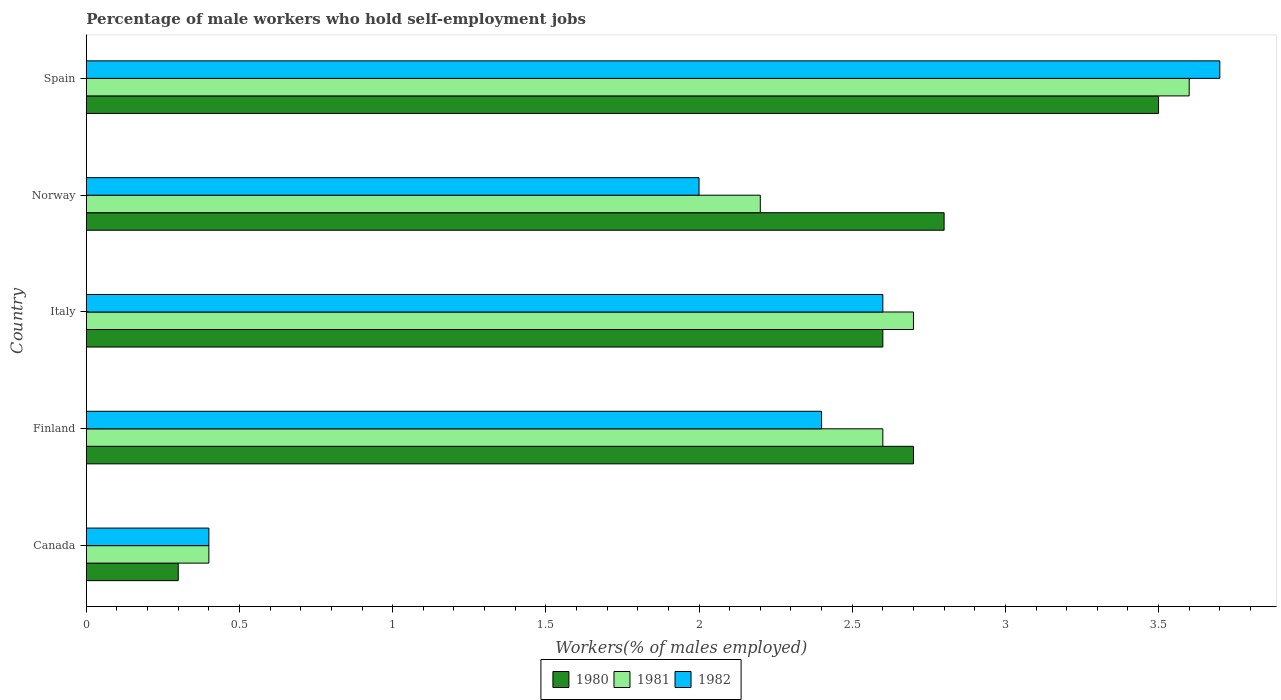Are the number of bars on each tick of the Y-axis equal?
Your answer should be very brief. Yes. How many bars are there on the 5th tick from the top?
Your response must be concise. 3. What is the label of the 4th group of bars from the top?
Ensure brevity in your answer.  Finland. What is the percentage of self-employed male workers in 1982 in Norway?
Give a very brief answer. 2. Across all countries, what is the maximum percentage of self-employed male workers in 1981?
Offer a terse response. 3.6. Across all countries, what is the minimum percentage of self-employed male workers in 1980?
Provide a short and direct response. 0.3. In which country was the percentage of self-employed male workers in 1982 maximum?
Give a very brief answer. Spain. In which country was the percentage of self-employed male workers in 1981 minimum?
Offer a very short reply. Canada. What is the total percentage of self-employed male workers in 1982 in the graph?
Offer a terse response. 11.1. What is the difference between the percentage of self-employed male workers in 1981 in Finland and that in Italy?
Offer a very short reply. -0.1. What is the difference between the percentage of self-employed male workers in 1980 in Spain and the percentage of self-employed male workers in 1981 in Canada?
Make the answer very short. 3.1. What is the average percentage of self-employed male workers in 1980 per country?
Your response must be concise. 2.38. What is the difference between the percentage of self-employed male workers in 1981 and percentage of self-employed male workers in 1980 in Canada?
Make the answer very short. 0.1. What is the ratio of the percentage of self-employed male workers in 1982 in Finland to that in Italy?
Keep it short and to the point. 0.92. Is the difference between the percentage of self-employed male workers in 1981 in Canada and Finland greater than the difference between the percentage of self-employed male workers in 1980 in Canada and Finland?
Provide a short and direct response. Yes. What is the difference between the highest and the second highest percentage of self-employed male workers in 1981?
Keep it short and to the point. 0.9. What is the difference between the highest and the lowest percentage of self-employed male workers in 1982?
Ensure brevity in your answer.  3.3. How many bars are there?
Your answer should be compact. 15. Are the values on the major ticks of X-axis written in scientific E-notation?
Offer a very short reply. No. Does the graph contain any zero values?
Offer a terse response. No. Where does the legend appear in the graph?
Your answer should be compact. Bottom center. How many legend labels are there?
Provide a short and direct response. 3. How are the legend labels stacked?
Your answer should be compact. Horizontal. What is the title of the graph?
Keep it short and to the point. Percentage of male workers who hold self-employment jobs. What is the label or title of the X-axis?
Keep it short and to the point. Workers(% of males employed). What is the Workers(% of males employed) of 1980 in Canada?
Offer a terse response. 0.3. What is the Workers(% of males employed) in 1981 in Canada?
Offer a very short reply. 0.4. What is the Workers(% of males employed) of 1982 in Canada?
Provide a succinct answer. 0.4. What is the Workers(% of males employed) in 1980 in Finland?
Make the answer very short. 2.7. What is the Workers(% of males employed) in 1981 in Finland?
Provide a succinct answer. 2.6. What is the Workers(% of males employed) in 1982 in Finland?
Offer a very short reply. 2.4. What is the Workers(% of males employed) of 1980 in Italy?
Ensure brevity in your answer.  2.6. What is the Workers(% of males employed) of 1981 in Italy?
Give a very brief answer. 2.7. What is the Workers(% of males employed) in 1982 in Italy?
Ensure brevity in your answer.  2.6. What is the Workers(% of males employed) in 1980 in Norway?
Provide a succinct answer. 2.8. What is the Workers(% of males employed) of 1981 in Norway?
Give a very brief answer. 2.2. What is the Workers(% of males employed) of 1981 in Spain?
Offer a very short reply. 3.6. What is the Workers(% of males employed) of 1982 in Spain?
Keep it short and to the point. 3.7. Across all countries, what is the maximum Workers(% of males employed) in 1980?
Offer a terse response. 3.5. Across all countries, what is the maximum Workers(% of males employed) of 1981?
Provide a short and direct response. 3.6. Across all countries, what is the maximum Workers(% of males employed) in 1982?
Your response must be concise. 3.7. Across all countries, what is the minimum Workers(% of males employed) of 1980?
Keep it short and to the point. 0.3. Across all countries, what is the minimum Workers(% of males employed) in 1981?
Make the answer very short. 0.4. Across all countries, what is the minimum Workers(% of males employed) of 1982?
Make the answer very short. 0.4. What is the total Workers(% of males employed) in 1980 in the graph?
Your response must be concise. 11.9. What is the total Workers(% of males employed) in 1982 in the graph?
Offer a terse response. 11.1. What is the difference between the Workers(% of males employed) in 1980 in Canada and that in Finland?
Provide a succinct answer. -2.4. What is the difference between the Workers(% of males employed) in 1981 in Canada and that in Finland?
Ensure brevity in your answer.  -2.2. What is the difference between the Workers(% of males employed) of 1982 in Canada and that in Finland?
Offer a very short reply. -2. What is the difference between the Workers(% of males employed) in 1980 in Canada and that in Italy?
Your answer should be very brief. -2.3. What is the difference between the Workers(% of males employed) of 1982 in Canada and that in Italy?
Provide a succinct answer. -2.2. What is the difference between the Workers(% of males employed) of 1982 in Canada and that in Norway?
Make the answer very short. -1.6. What is the difference between the Workers(% of males employed) in 1980 in Canada and that in Spain?
Your response must be concise. -3.2. What is the difference between the Workers(% of males employed) of 1981 in Canada and that in Spain?
Offer a very short reply. -3.2. What is the difference between the Workers(% of males employed) in 1982 in Canada and that in Spain?
Ensure brevity in your answer.  -3.3. What is the difference between the Workers(% of males employed) of 1981 in Finland and that in Italy?
Provide a short and direct response. -0.1. What is the difference between the Workers(% of males employed) in 1980 in Finland and that in Norway?
Your response must be concise. -0.1. What is the difference between the Workers(% of males employed) in 1980 in Italy and that in Spain?
Provide a short and direct response. -0.9. What is the difference between the Workers(% of males employed) of 1981 in Italy and that in Spain?
Your response must be concise. -0.9. What is the difference between the Workers(% of males employed) of 1980 in Norway and that in Spain?
Offer a very short reply. -0.7. What is the difference between the Workers(% of males employed) of 1982 in Norway and that in Spain?
Your response must be concise. -1.7. What is the difference between the Workers(% of males employed) in 1980 in Canada and the Workers(% of males employed) in 1981 in Finland?
Offer a terse response. -2.3. What is the difference between the Workers(% of males employed) in 1980 in Canada and the Workers(% of males employed) in 1982 in Finland?
Offer a terse response. -2.1. What is the difference between the Workers(% of males employed) of 1981 in Canada and the Workers(% of males employed) of 1982 in Finland?
Ensure brevity in your answer.  -2. What is the difference between the Workers(% of males employed) of 1980 in Canada and the Workers(% of males employed) of 1981 in Italy?
Provide a short and direct response. -2.4. What is the difference between the Workers(% of males employed) of 1980 in Canada and the Workers(% of males employed) of 1982 in Italy?
Give a very brief answer. -2.3. What is the difference between the Workers(% of males employed) in 1981 in Canada and the Workers(% of males employed) in 1982 in Italy?
Offer a very short reply. -2.2. What is the difference between the Workers(% of males employed) of 1980 in Canada and the Workers(% of males employed) of 1982 in Norway?
Your answer should be compact. -1.7. What is the difference between the Workers(% of males employed) of 1981 in Canada and the Workers(% of males employed) of 1982 in Norway?
Keep it short and to the point. -1.6. What is the difference between the Workers(% of males employed) in 1980 in Finland and the Workers(% of males employed) in 1981 in Italy?
Give a very brief answer. 0. What is the difference between the Workers(% of males employed) of 1980 in Finland and the Workers(% of males employed) of 1982 in Italy?
Give a very brief answer. 0.1. What is the difference between the Workers(% of males employed) of 1981 in Finland and the Workers(% of males employed) of 1982 in Italy?
Ensure brevity in your answer.  0. What is the difference between the Workers(% of males employed) of 1980 in Finland and the Workers(% of males employed) of 1981 in Norway?
Your response must be concise. 0.5. What is the difference between the Workers(% of males employed) of 1980 in Finland and the Workers(% of males employed) of 1982 in Norway?
Offer a terse response. 0.7. What is the difference between the Workers(% of males employed) of 1980 in Finland and the Workers(% of males employed) of 1982 in Spain?
Offer a very short reply. -1. What is the difference between the Workers(% of males employed) in 1980 in Italy and the Workers(% of males employed) in 1981 in Norway?
Provide a succinct answer. 0.4. What is the difference between the Workers(% of males employed) of 1980 in Italy and the Workers(% of males employed) of 1982 in Norway?
Give a very brief answer. 0.6. What is the difference between the Workers(% of males employed) of 1981 in Italy and the Workers(% of males employed) of 1982 in Spain?
Offer a very short reply. -1. What is the difference between the Workers(% of males employed) in 1981 in Norway and the Workers(% of males employed) in 1982 in Spain?
Ensure brevity in your answer.  -1.5. What is the average Workers(% of males employed) in 1980 per country?
Your response must be concise. 2.38. What is the average Workers(% of males employed) of 1982 per country?
Your answer should be very brief. 2.22. What is the difference between the Workers(% of males employed) in 1980 and Workers(% of males employed) in 1981 in Canada?
Ensure brevity in your answer.  -0.1. What is the difference between the Workers(% of males employed) in 1980 and Workers(% of males employed) in 1981 in Finland?
Keep it short and to the point. 0.1. What is the difference between the Workers(% of males employed) of 1980 and Workers(% of males employed) of 1981 in Italy?
Provide a short and direct response. -0.1. What is the difference between the Workers(% of males employed) of 1980 and Workers(% of males employed) of 1982 in Italy?
Ensure brevity in your answer.  0. What is the difference between the Workers(% of males employed) of 1980 and Workers(% of males employed) of 1981 in Norway?
Provide a short and direct response. 0.6. What is the difference between the Workers(% of males employed) in 1980 and Workers(% of males employed) in 1982 in Norway?
Your response must be concise. 0.8. What is the difference between the Workers(% of males employed) in 1981 and Workers(% of males employed) in 1982 in Spain?
Give a very brief answer. -0.1. What is the ratio of the Workers(% of males employed) of 1980 in Canada to that in Finland?
Offer a terse response. 0.11. What is the ratio of the Workers(% of males employed) of 1981 in Canada to that in Finland?
Your answer should be compact. 0.15. What is the ratio of the Workers(% of males employed) of 1980 in Canada to that in Italy?
Your answer should be very brief. 0.12. What is the ratio of the Workers(% of males employed) in 1981 in Canada to that in Italy?
Your answer should be compact. 0.15. What is the ratio of the Workers(% of males employed) of 1982 in Canada to that in Italy?
Keep it short and to the point. 0.15. What is the ratio of the Workers(% of males employed) of 1980 in Canada to that in Norway?
Your response must be concise. 0.11. What is the ratio of the Workers(% of males employed) in 1981 in Canada to that in Norway?
Provide a short and direct response. 0.18. What is the ratio of the Workers(% of males employed) in 1982 in Canada to that in Norway?
Give a very brief answer. 0.2. What is the ratio of the Workers(% of males employed) of 1980 in Canada to that in Spain?
Offer a very short reply. 0.09. What is the ratio of the Workers(% of males employed) in 1982 in Canada to that in Spain?
Give a very brief answer. 0.11. What is the ratio of the Workers(% of males employed) of 1980 in Finland to that in Italy?
Provide a succinct answer. 1.04. What is the ratio of the Workers(% of males employed) in 1980 in Finland to that in Norway?
Give a very brief answer. 0.96. What is the ratio of the Workers(% of males employed) in 1981 in Finland to that in Norway?
Make the answer very short. 1.18. What is the ratio of the Workers(% of males employed) in 1980 in Finland to that in Spain?
Your answer should be very brief. 0.77. What is the ratio of the Workers(% of males employed) in 1981 in Finland to that in Spain?
Offer a terse response. 0.72. What is the ratio of the Workers(% of males employed) of 1982 in Finland to that in Spain?
Give a very brief answer. 0.65. What is the ratio of the Workers(% of males employed) of 1981 in Italy to that in Norway?
Your answer should be compact. 1.23. What is the ratio of the Workers(% of males employed) of 1982 in Italy to that in Norway?
Make the answer very short. 1.3. What is the ratio of the Workers(% of males employed) in 1980 in Italy to that in Spain?
Make the answer very short. 0.74. What is the ratio of the Workers(% of males employed) in 1981 in Italy to that in Spain?
Offer a very short reply. 0.75. What is the ratio of the Workers(% of males employed) in 1982 in Italy to that in Spain?
Your response must be concise. 0.7. What is the ratio of the Workers(% of males employed) of 1980 in Norway to that in Spain?
Your answer should be very brief. 0.8. What is the ratio of the Workers(% of males employed) in 1981 in Norway to that in Spain?
Make the answer very short. 0.61. What is the ratio of the Workers(% of males employed) in 1982 in Norway to that in Spain?
Provide a succinct answer. 0.54. What is the difference between the highest and the second highest Workers(% of males employed) of 1980?
Your answer should be compact. 0.7. What is the difference between the highest and the second highest Workers(% of males employed) of 1981?
Give a very brief answer. 0.9. What is the difference between the highest and the second highest Workers(% of males employed) of 1982?
Give a very brief answer. 1.1. What is the difference between the highest and the lowest Workers(% of males employed) of 1980?
Your answer should be compact. 3.2. What is the difference between the highest and the lowest Workers(% of males employed) of 1982?
Provide a short and direct response. 3.3. 